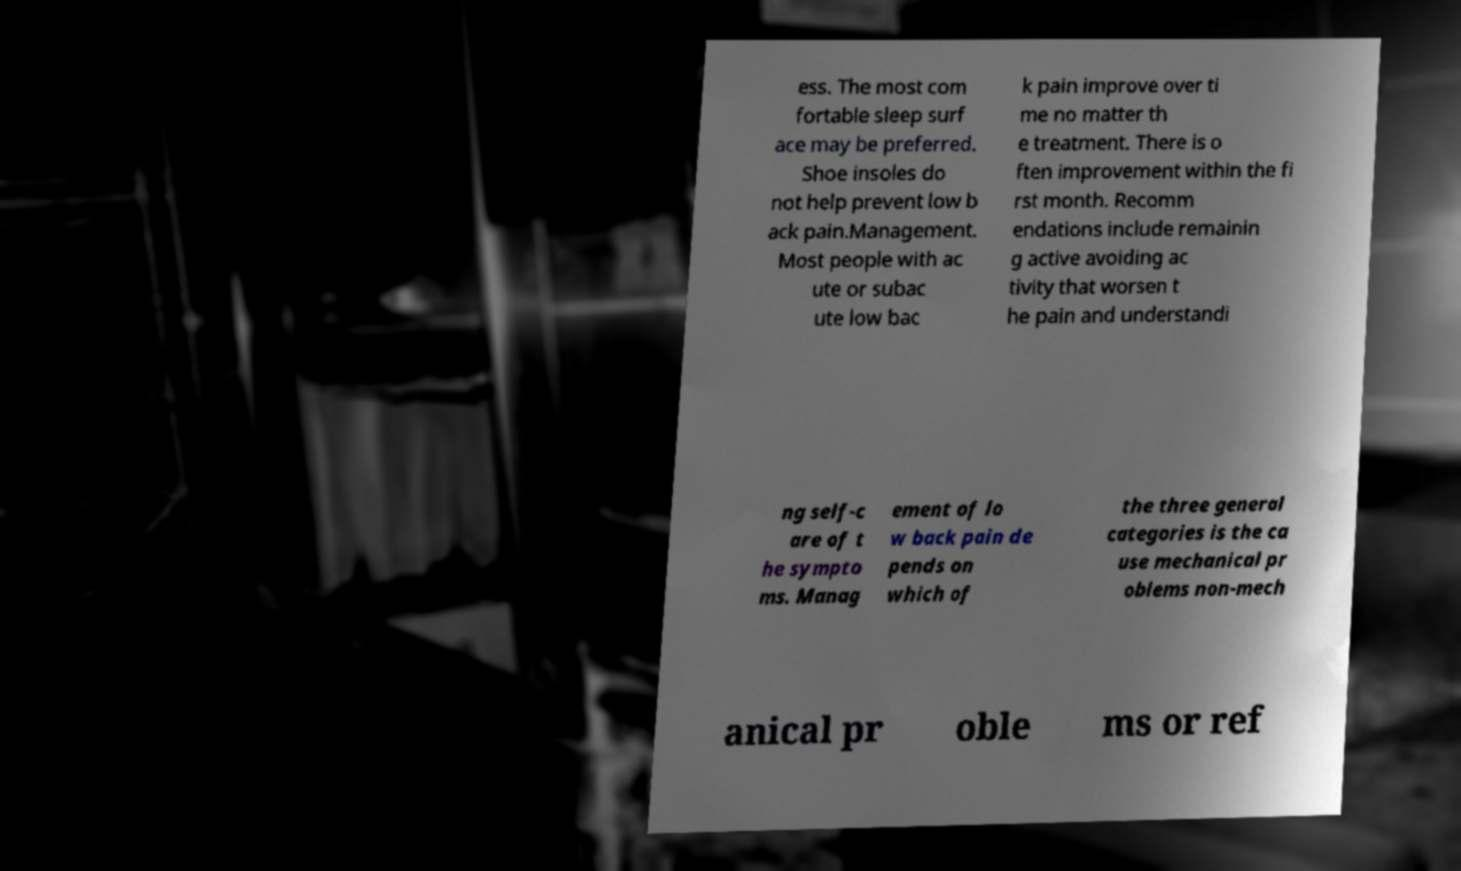Could you extract and type out the text from this image? ess. The most com fortable sleep surf ace may be preferred. Shoe insoles do not help prevent low b ack pain.Management. Most people with ac ute or subac ute low bac k pain improve over ti me no matter th e treatment. There is o ften improvement within the fi rst month. Recomm endations include remainin g active avoiding ac tivity that worsen t he pain and understandi ng self-c are of t he sympto ms. Manag ement of lo w back pain de pends on which of the three general categories is the ca use mechanical pr oblems non-mech anical pr oble ms or ref 